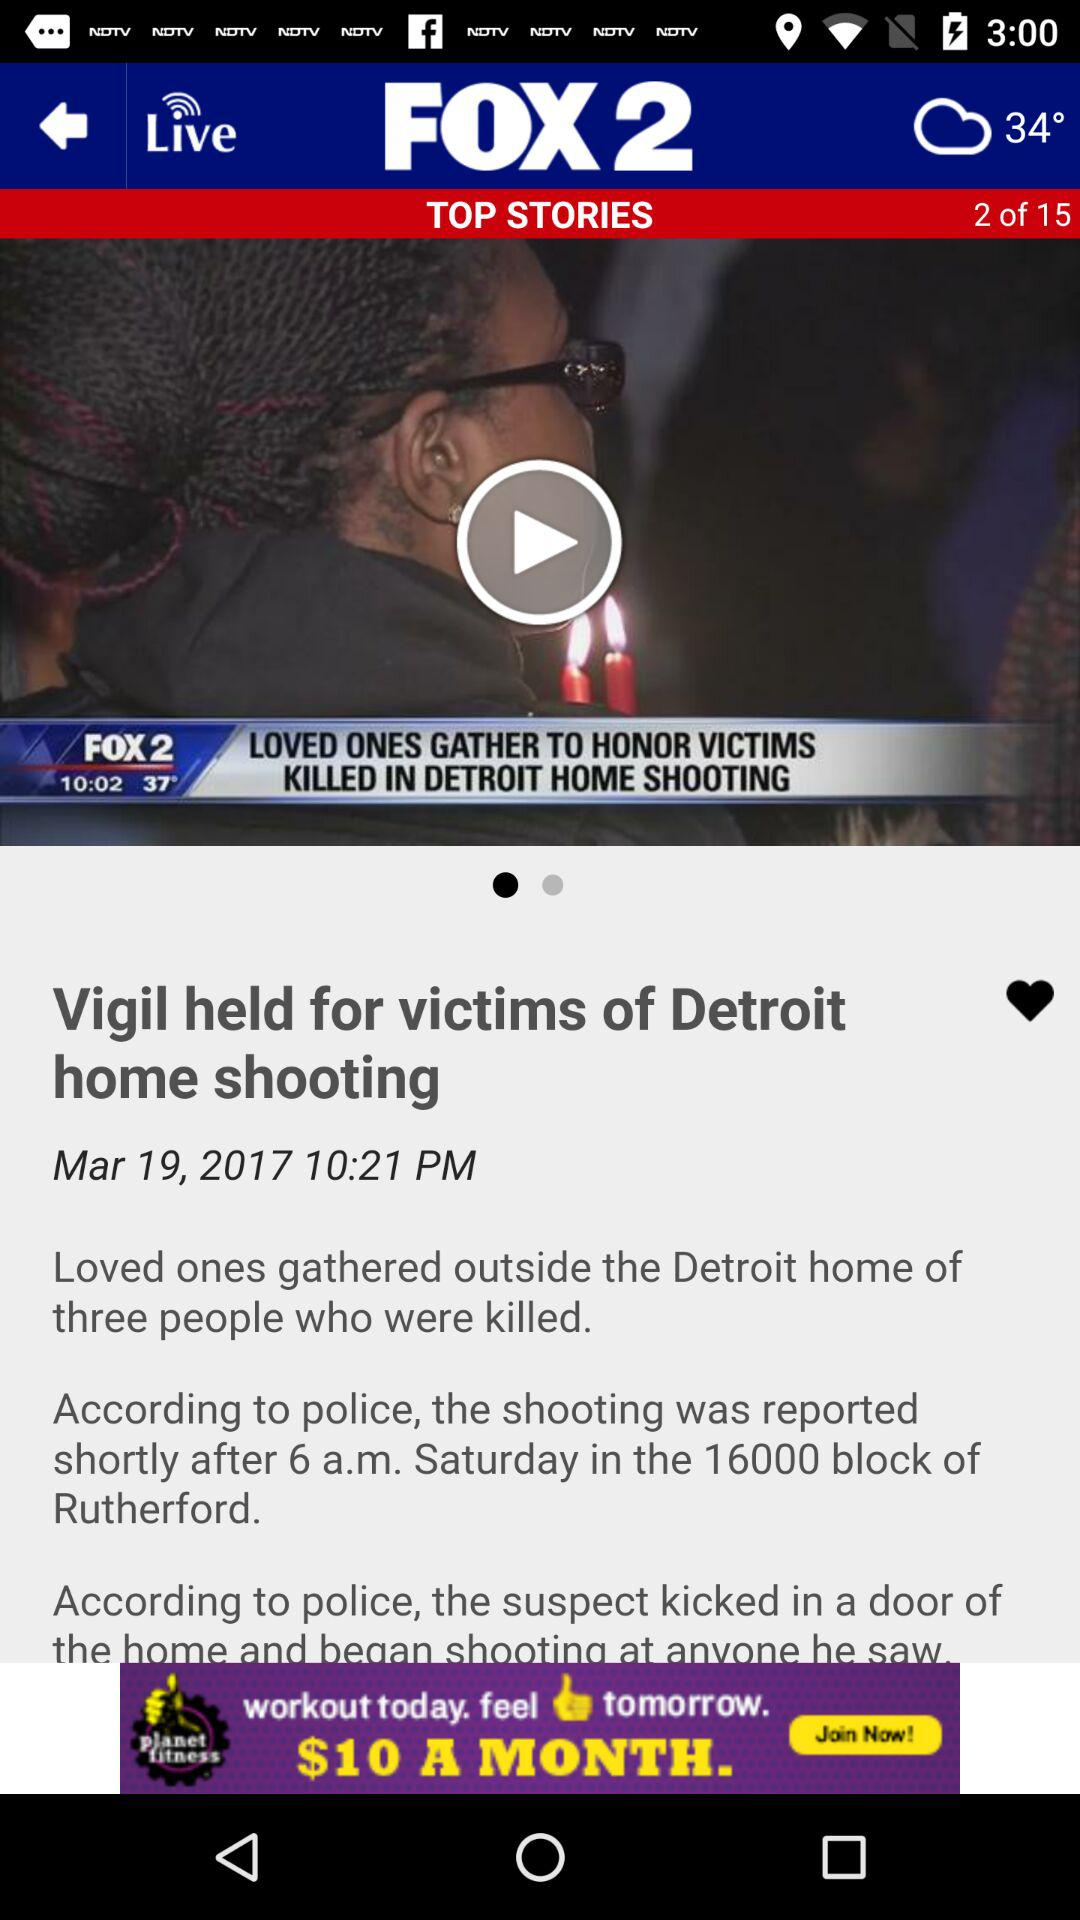What type of weather is showing on the screen?
When the provided information is insufficient, respond with <no answer>. <no answer> 